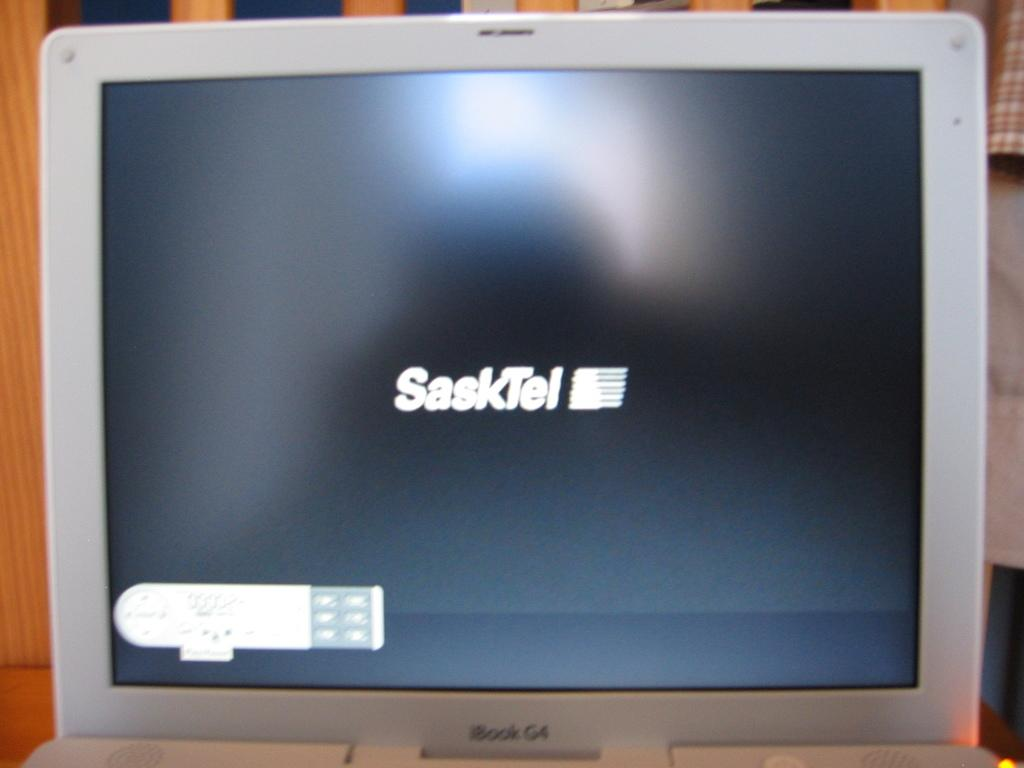<image>
Share a concise interpretation of the image provided. Computer screen which says Sasktel on it in white. 